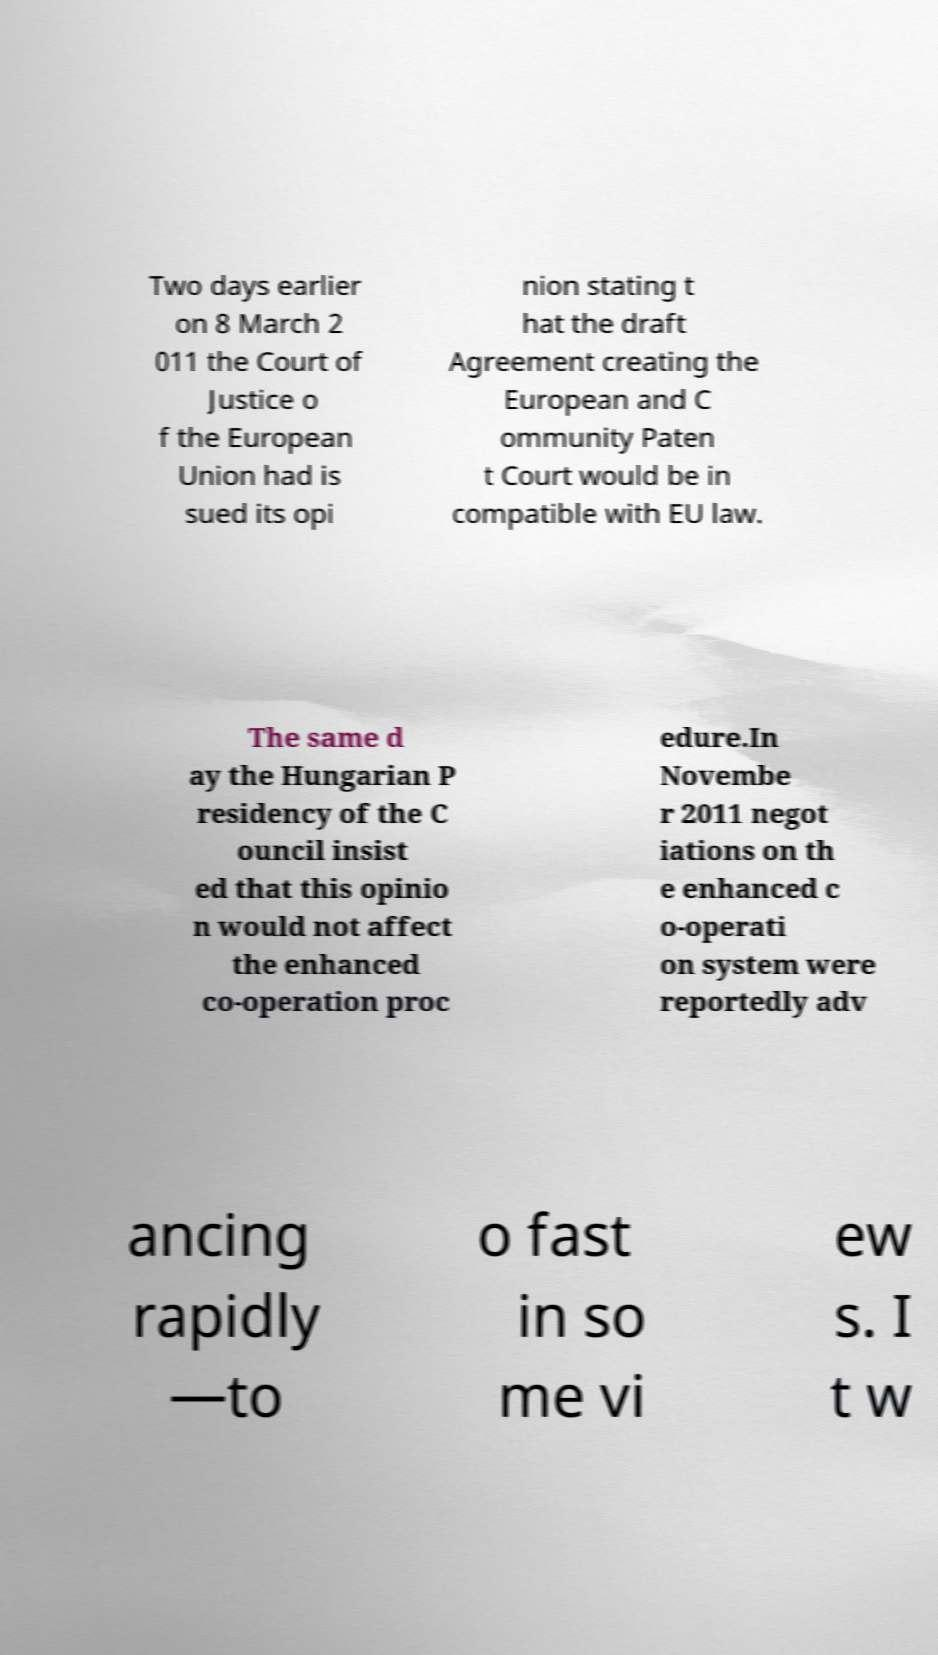Please read and relay the text visible in this image. What does it say? Two days earlier on 8 March 2 011 the Court of Justice o f the European Union had is sued its opi nion stating t hat the draft Agreement creating the European and C ommunity Paten t Court would be in compatible with EU law. The same d ay the Hungarian P residency of the C ouncil insist ed that this opinio n would not affect the enhanced co-operation proc edure.In Novembe r 2011 negot iations on th e enhanced c o-operati on system were reportedly adv ancing rapidly —to o fast in so me vi ew s. I t w 